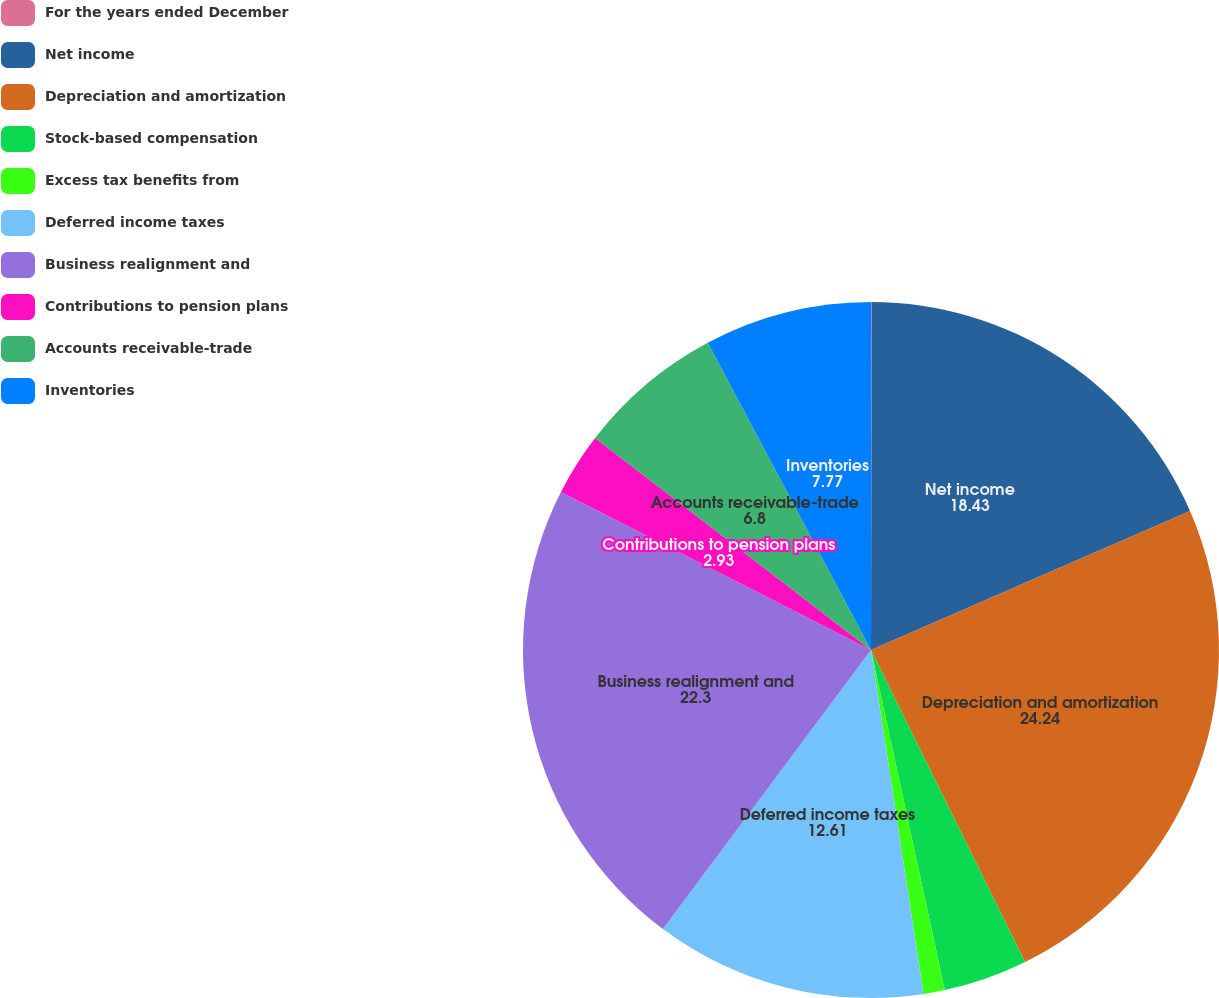Convert chart. <chart><loc_0><loc_0><loc_500><loc_500><pie_chart><fcel>For the years ended December<fcel>Net income<fcel>Depreciation and amortization<fcel>Stock-based compensation<fcel>Excess tax benefits from<fcel>Deferred income taxes<fcel>Business realignment and<fcel>Contributions to pension plans<fcel>Accounts receivable-trade<fcel>Inventories<nl><fcel>0.03%<fcel>18.43%<fcel>24.24%<fcel>3.9%<fcel>0.99%<fcel>12.61%<fcel>22.3%<fcel>2.93%<fcel>6.8%<fcel>7.77%<nl></chart> 